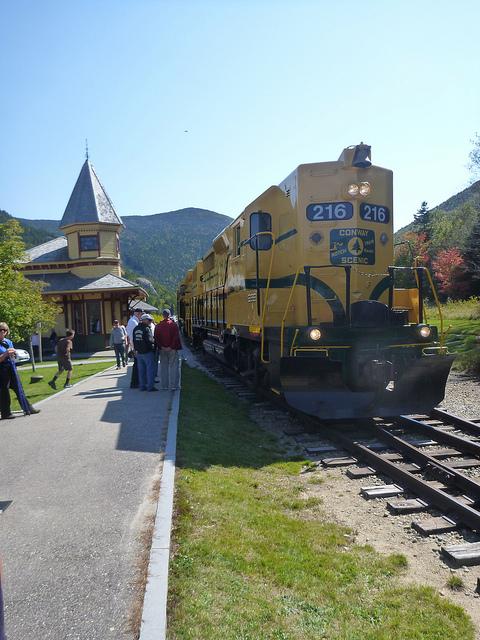What color is the train?
Quick response, please. Yellow. What number is the train?
Be succinct. 216. Are there any clouds in the sky?
Keep it brief. No. 